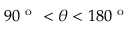<formula> <loc_0><loc_0><loc_500><loc_500>9 0 ^ { o } < \theta < 1 8 0 ^ { o }</formula> 